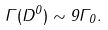Convert formula to latex. <formula><loc_0><loc_0><loc_500><loc_500>\Gamma ( D ^ { 0 } ) \sim 9 \Gamma _ { 0 } .</formula> 